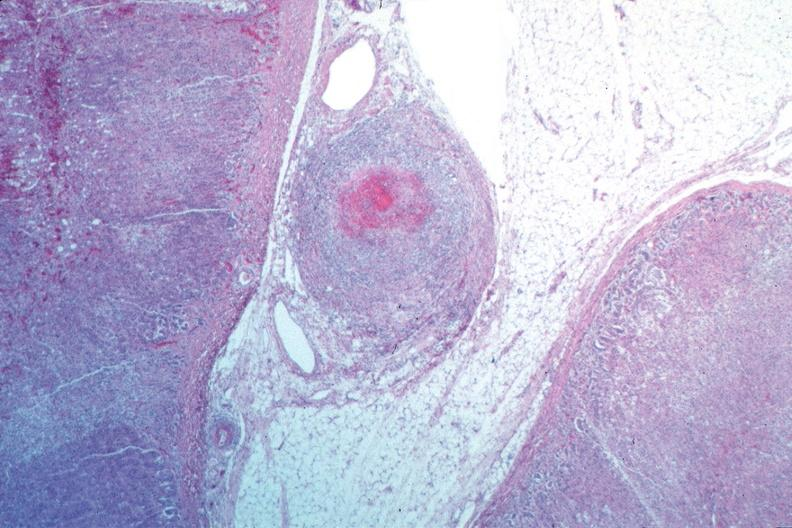s lower chest and abdomen anterior present?
Answer the question using a single word or phrase. No 